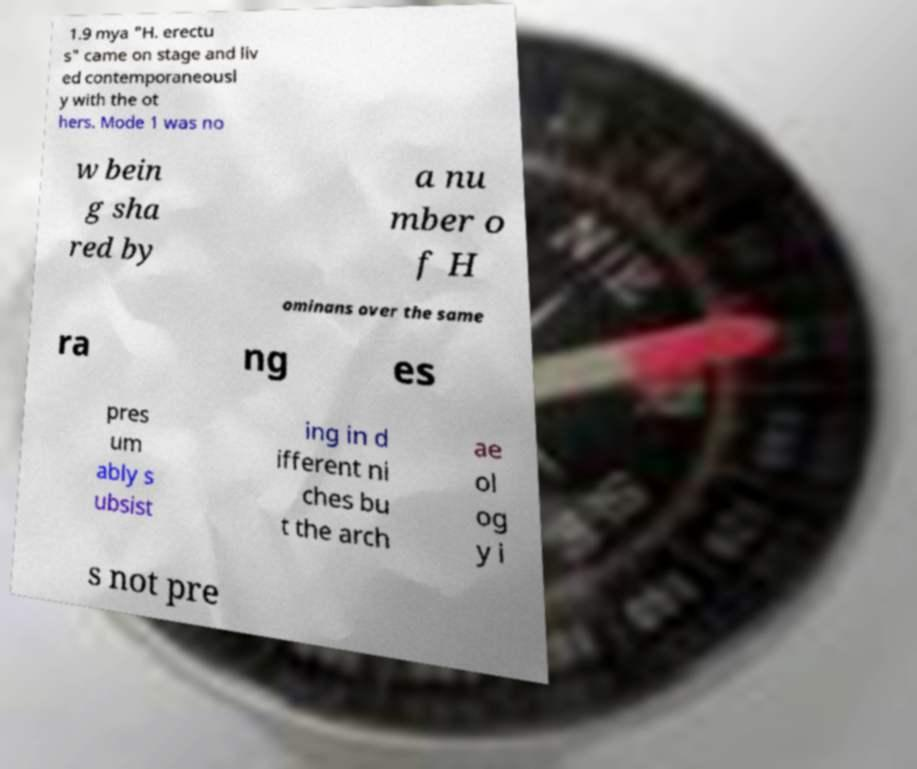Could you extract and type out the text from this image? 1.9 mya "H. erectu s" came on stage and liv ed contemporaneousl y with the ot hers. Mode 1 was no w bein g sha red by a nu mber o f H ominans over the same ra ng es pres um ably s ubsist ing in d ifferent ni ches bu t the arch ae ol og y i s not pre 